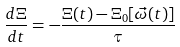<formula> <loc_0><loc_0><loc_500><loc_500>\frac { d \Xi } { d t } = - \frac { \Xi ( t ) - \Xi _ { 0 } [ \vec { \omega } ( t ) ] } { \tau }</formula> 